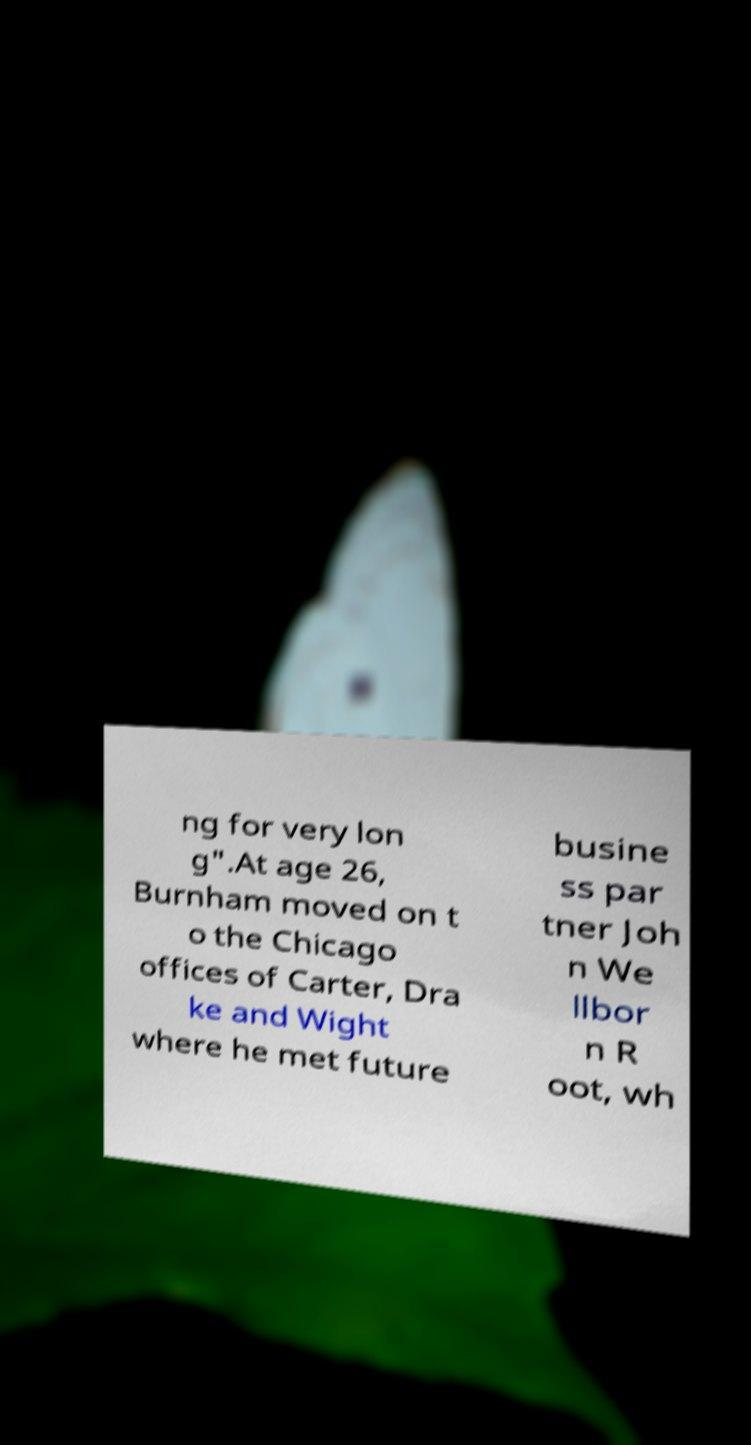For documentation purposes, I need the text within this image transcribed. Could you provide that? ng for very lon g".At age 26, Burnham moved on t o the Chicago offices of Carter, Dra ke and Wight where he met future busine ss par tner Joh n We llbor n R oot, wh 